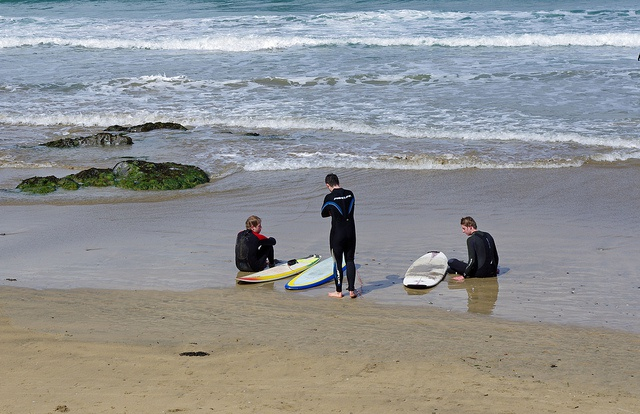Describe the objects in this image and their specific colors. I can see people in teal, black, darkgray, gray, and navy tones, people in teal, black, gray, darkgray, and lightpink tones, people in teal, black, darkgray, gray, and maroon tones, surfboard in teal, lightgray, darkgray, black, and gray tones, and surfboard in teal, lightgray, black, darkgray, and beige tones in this image. 